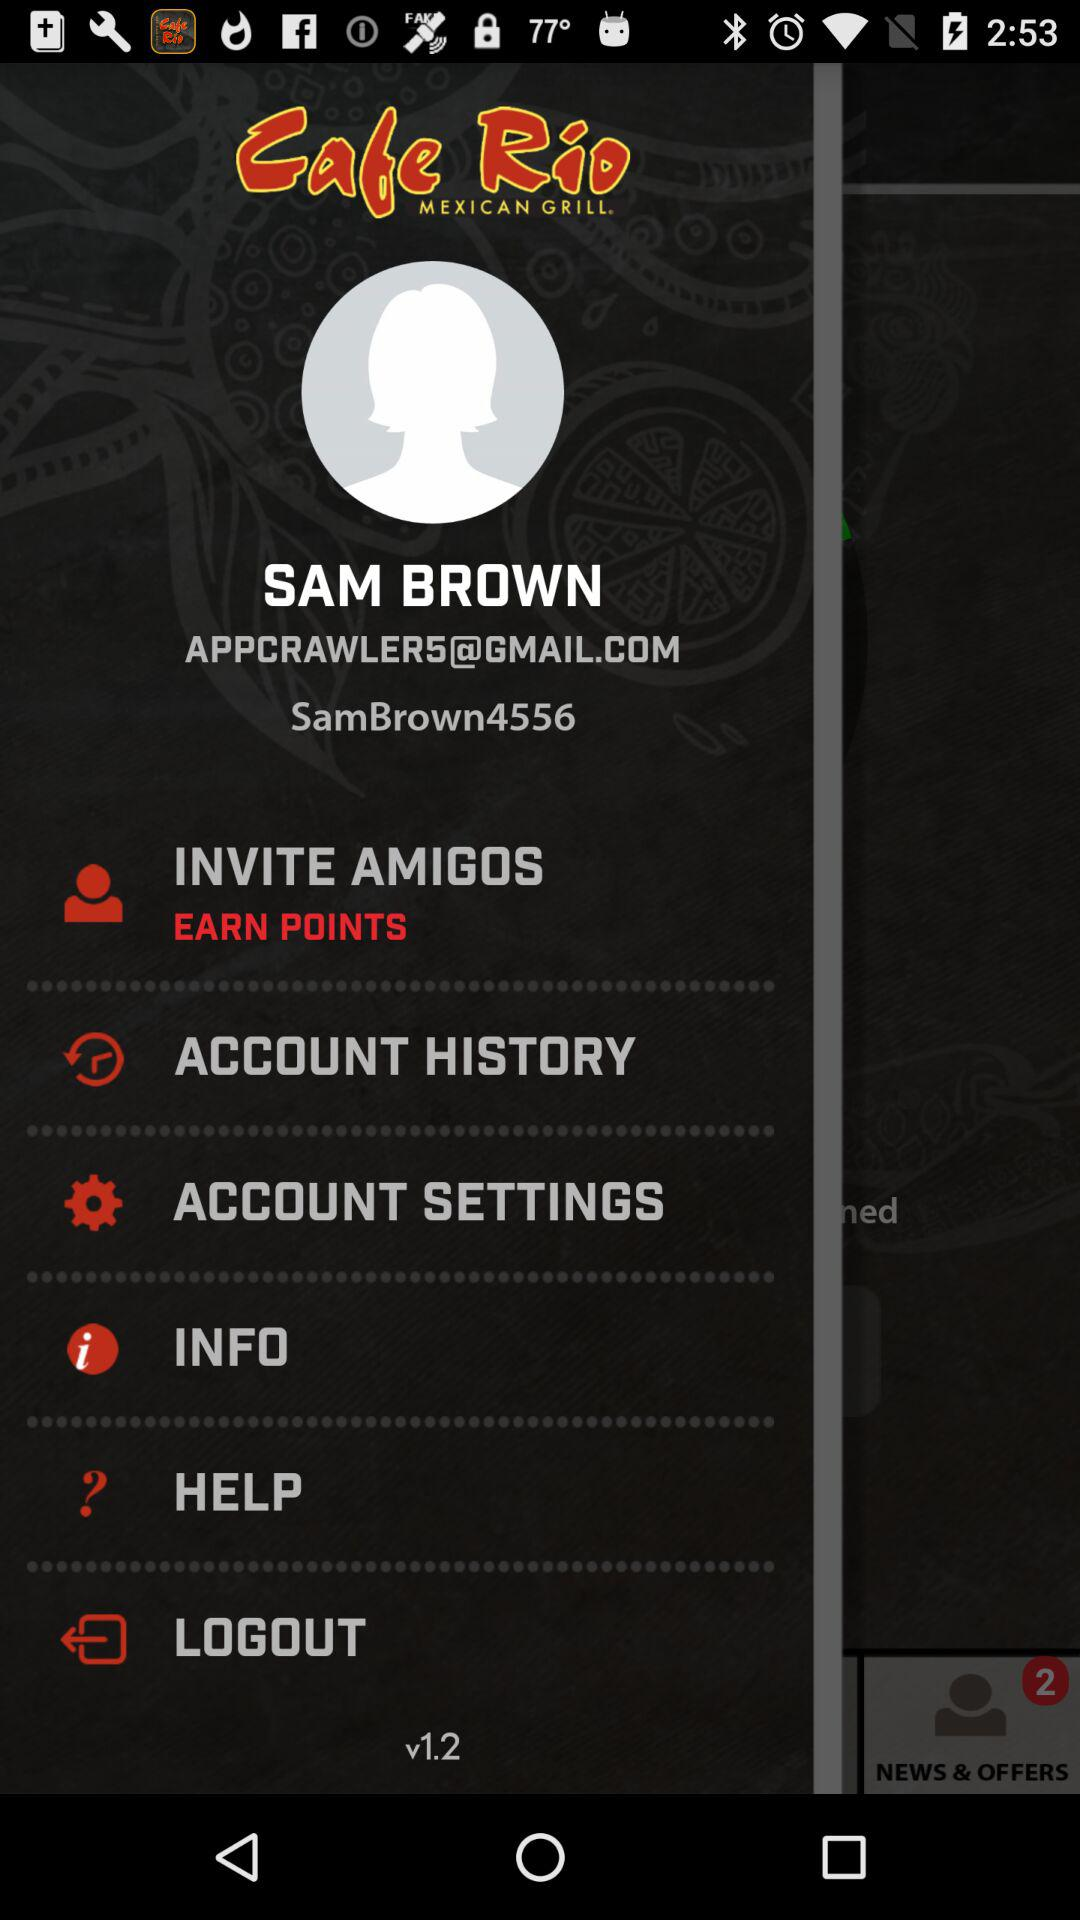What is the version of the application? The version of the application is v1.2. 